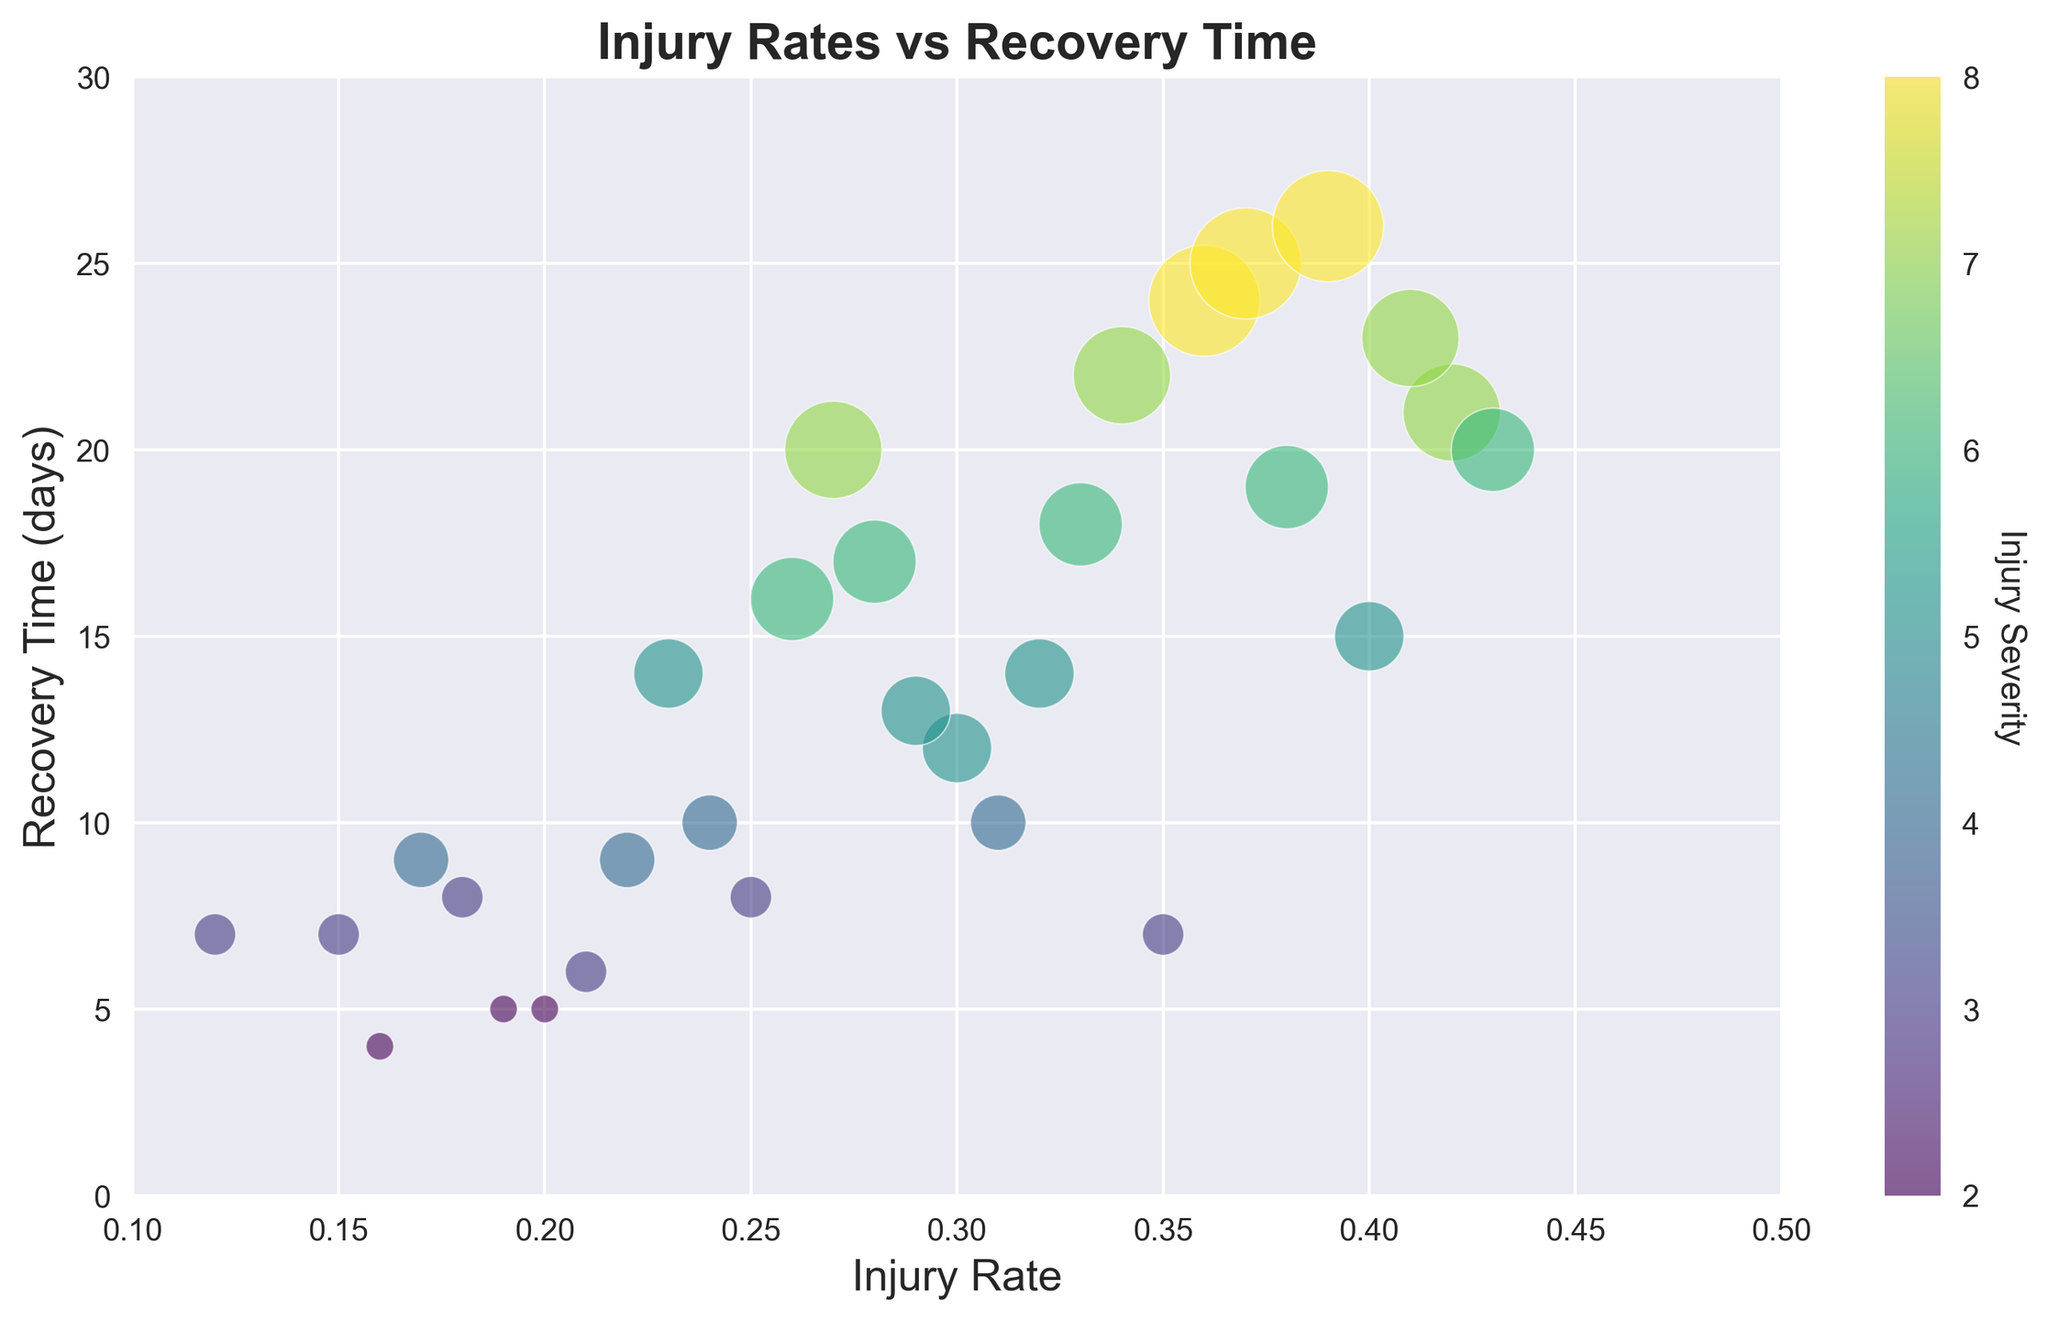How does the injury rate relate to recovery time? By observing the scatter plot, a relationship between the x-axis (injury rate) and the y-axis (recovery time) can be inferred. The points color and size factor in injury severity as well. Generally, higher injury rates correspond to longer recovery times.
Answer: Higher injury rates correspond to longer recovery times What is the range of injury rates observed in the figure? To determine the range, find the minimum and maximum values on the x-axis where the points are plotted. From the scatter plot, the smallest injury rate is near 0.12 and the highest is around 0.43.
Answer: 0.12 to 0.43 Does a higher injury severity necessarily lead to a longer recovery time? Examine the colors of the points and their vertical positions on the scatter plot. Although many higher severity injuries (darker colored points) do have longer recovery times, it's not always the case since other factors might influence recovery.
Answer: Not necessarily Which player has the longest recovery time and what is their injury rate? Identify the highest point on the y-axis (representing recovery time). The highest point is around 26 days, and upon checking the corresponding x-axis value, the injury rate is around 0.39.
Answer: Player with injury rate 0.39 (PlayerID 23) What is the average recovery time for players with an injury rate above 0.30? Identify points with an x-axis value greater than 0.30. Calculate the average of their y-axis values (recovery times). The relevant recovery times are 21, 17, 24, 18, 20, 22, 25, 19, 26, 23, and 15 days. The average is (21+17+24+18+20+22+25+19+26+23+15)/11.
Answer: 20.0 days Which injury severity levels are associated with injury rates around 0.25 to 0.30? Look for points plotted between 0.25 and 0.30 on the x-axis and check their colors and sizes, which denote severity. The severities for these points are 3, 4, 5, and 6.
Answer: Severities 3, 4, 5, and 6 Compare the recovery times of players with the nearly same severity but different injury rates. Pick points with the same or nearly same sizes but varying x-axis values (injury rates). For example, players with severity 5: one point near 0.23 has a recovery time of 14 and another point near 0.30 has a recovery time of 13. This highlights variability in recovery times even with similar injury severities.
Answer: Recovery times vary even with the same severity Which recovery time corresponds to the highest injury severity observed? Identify the darkest colored and largest points, as they represent the highest injury severity (8). Check their vertical positions on the y-axis. The two recovery times for severity 8 are 24 and 26 days.
Answer: 26 days 